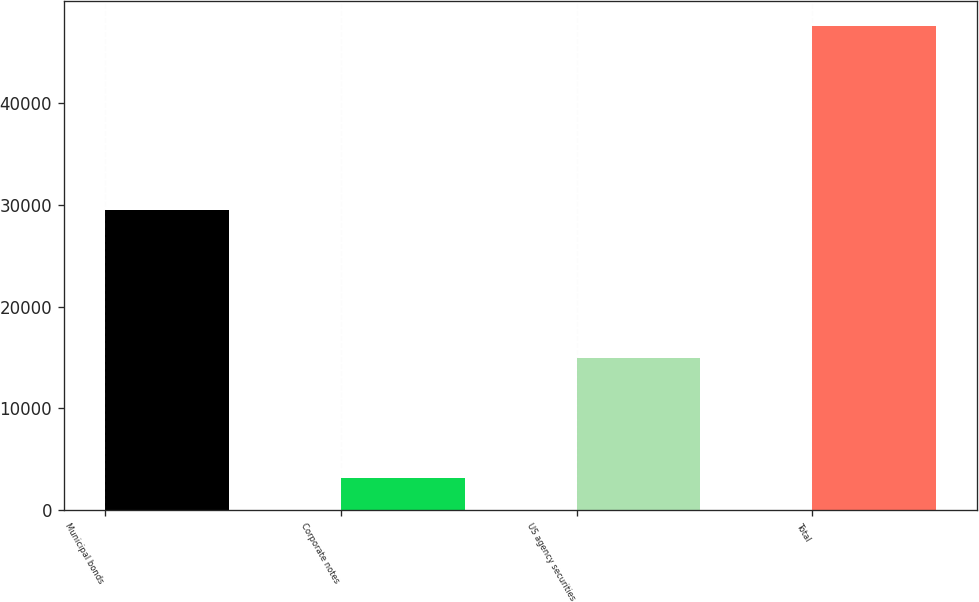Convert chart. <chart><loc_0><loc_0><loc_500><loc_500><bar_chart><fcel>Municipal bonds<fcel>Corporate notes<fcel>US agency securities<fcel>Total<nl><fcel>29484<fcel>3151<fcel>14964<fcel>47599<nl></chart> 